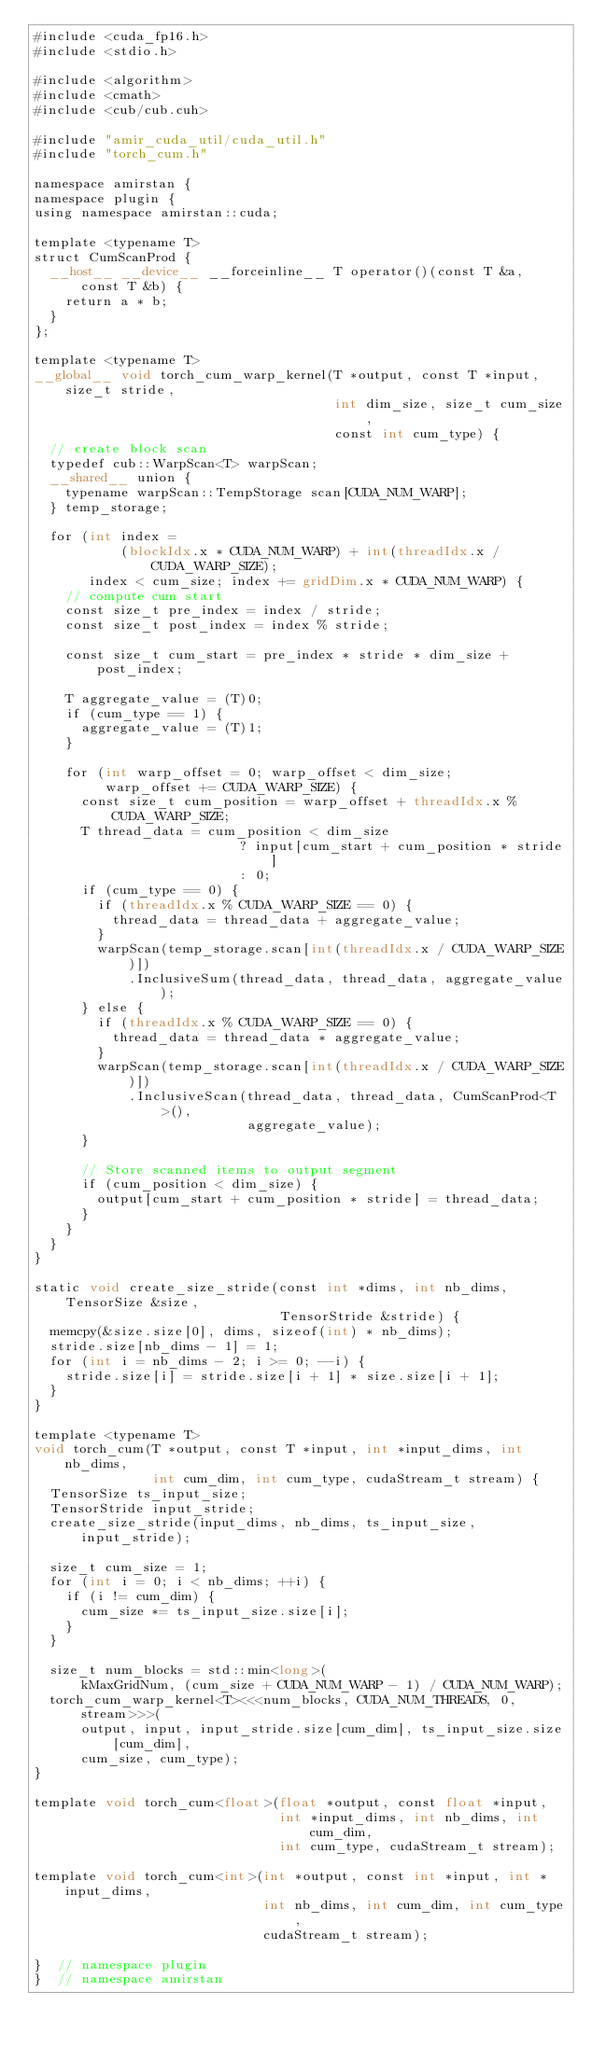<code> <loc_0><loc_0><loc_500><loc_500><_Cuda_>#include <cuda_fp16.h>
#include <stdio.h>

#include <algorithm>
#include <cmath>
#include <cub/cub.cuh>

#include "amir_cuda_util/cuda_util.h"
#include "torch_cum.h"

namespace amirstan {
namespace plugin {
using namespace amirstan::cuda;

template <typename T>
struct CumScanProd {
  __host__ __device__ __forceinline__ T operator()(const T &a, const T &b) {
    return a * b;
  }
};

template <typename T>
__global__ void torch_cum_warp_kernel(T *output, const T *input, size_t stride,
                                      int dim_size, size_t cum_size,
                                      const int cum_type) {
  // create block scan
  typedef cub::WarpScan<T> warpScan;
  __shared__ union {
    typename warpScan::TempStorage scan[CUDA_NUM_WARP];
  } temp_storage;

  for (int index =
           (blockIdx.x * CUDA_NUM_WARP) + int(threadIdx.x / CUDA_WARP_SIZE);
       index < cum_size; index += gridDim.x * CUDA_NUM_WARP) {
    // compute cum start
    const size_t pre_index = index / stride;
    const size_t post_index = index % stride;

    const size_t cum_start = pre_index * stride * dim_size + post_index;

    T aggregate_value = (T)0;
    if (cum_type == 1) {
      aggregate_value = (T)1;
    }

    for (int warp_offset = 0; warp_offset < dim_size;
         warp_offset += CUDA_WARP_SIZE) {
      const size_t cum_position = warp_offset + threadIdx.x % CUDA_WARP_SIZE;
      T thread_data = cum_position < dim_size
                          ? input[cum_start + cum_position * stride]
                          : 0;
      if (cum_type == 0) {
        if (threadIdx.x % CUDA_WARP_SIZE == 0) {
          thread_data = thread_data + aggregate_value;
        }
        warpScan(temp_storage.scan[int(threadIdx.x / CUDA_WARP_SIZE)])
            .InclusiveSum(thread_data, thread_data, aggregate_value);
      } else {
        if (threadIdx.x % CUDA_WARP_SIZE == 0) {
          thread_data = thread_data * aggregate_value;
        }
        warpScan(temp_storage.scan[int(threadIdx.x / CUDA_WARP_SIZE)])
            .InclusiveScan(thread_data, thread_data, CumScanProd<T>(),
                           aggregate_value);
      }

      // Store scanned items to output segment
      if (cum_position < dim_size) {
        output[cum_start + cum_position * stride] = thread_data;
      }
    }
  }
}

static void create_size_stride(const int *dims, int nb_dims, TensorSize &size,
                               TensorStride &stride) {
  memcpy(&size.size[0], dims, sizeof(int) * nb_dims);
  stride.size[nb_dims - 1] = 1;
  for (int i = nb_dims - 2; i >= 0; --i) {
    stride.size[i] = stride.size[i + 1] * size.size[i + 1];
  }
}

template <typename T>
void torch_cum(T *output, const T *input, int *input_dims, int nb_dims,
               int cum_dim, int cum_type, cudaStream_t stream) {
  TensorSize ts_input_size;
  TensorStride input_stride;
  create_size_stride(input_dims, nb_dims, ts_input_size, input_stride);

  size_t cum_size = 1;
  for (int i = 0; i < nb_dims; ++i) {
    if (i != cum_dim) {
      cum_size *= ts_input_size.size[i];
    }
  }

  size_t num_blocks = std::min<long>(
      kMaxGridNum, (cum_size + CUDA_NUM_WARP - 1) / CUDA_NUM_WARP);
  torch_cum_warp_kernel<T><<<num_blocks, CUDA_NUM_THREADS, 0, stream>>>(
      output, input, input_stride.size[cum_dim], ts_input_size.size[cum_dim],
      cum_size, cum_type);
}

template void torch_cum<float>(float *output, const float *input,
                               int *input_dims, int nb_dims, int cum_dim,
                               int cum_type, cudaStream_t stream);

template void torch_cum<int>(int *output, const int *input, int *input_dims,
                             int nb_dims, int cum_dim, int cum_type,
                             cudaStream_t stream);

}  // namespace plugin
}  // namespace amirstan
</code> 